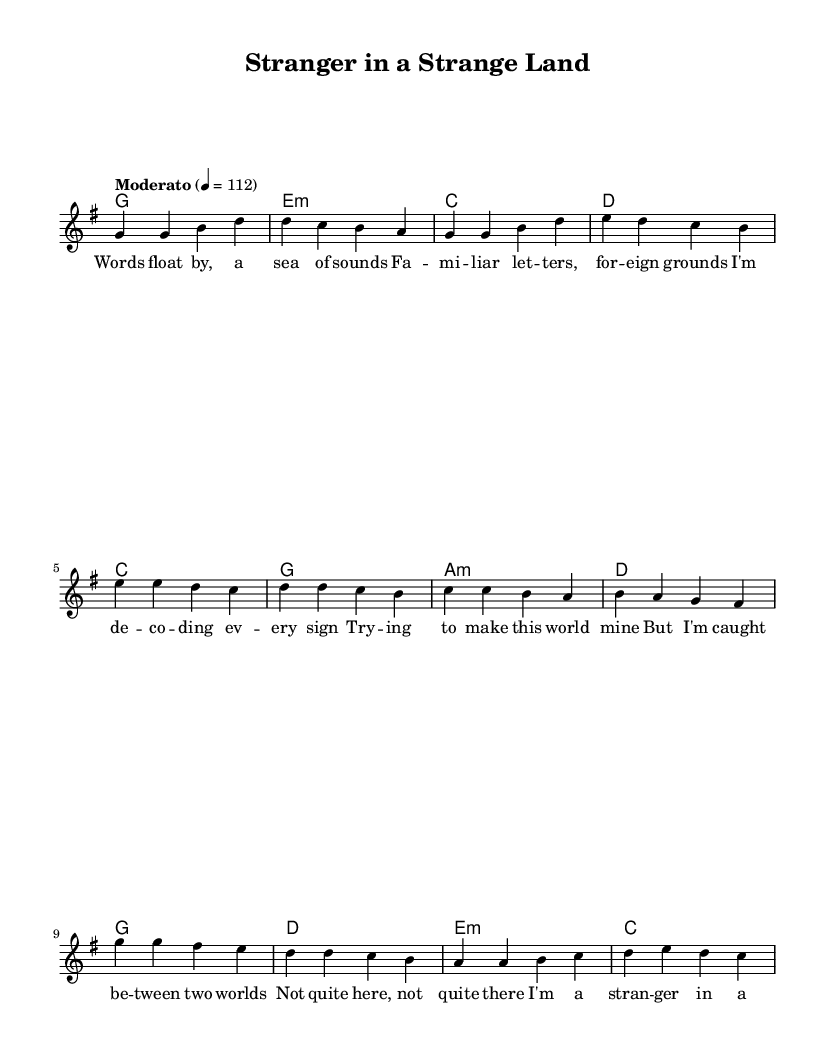What is the key signature of this piece? The key signature indicates that there is one sharp, which corresponds to the G major scale.
Answer: G major What is the time signature of this music? The time signature is indicated at the beginning of the sheet music, which shows that each measure contains four beats.
Answer: 4/4 What is the tempo marking for this song? The tempo is specified as "Moderato," which generally means a moderate speed, and it is set at 112 beats per minute.
Answer: Moderato How many measures are there in the verse? The verse includes four measures as indicated by the grouping of notes and chord changes.
Answer: 4 Which chord follows the first melody note in the verse? The first melody note in the verse is G, and the corresponding chord is G major. This can be seen in the chord mode section aligned with the melody.
Answer: G How does the pre-chorus differ from the verse in terms of lyrical content? The pre-chorus expresses a feeling of being caught between two worlds, contrasting with the verse that describes decoding and familiarizing oneself with a new environment. This reflects a shift from observation to internal conflict.
Answer: Internal conflict Identify the overall theme of the chorus. The chorus emphasizes feeling like a stranger in an unfamiliar land and trying to adapt to cultural nuances, encapsulating the theme of cultural identity.
Answer: Cultural identity 